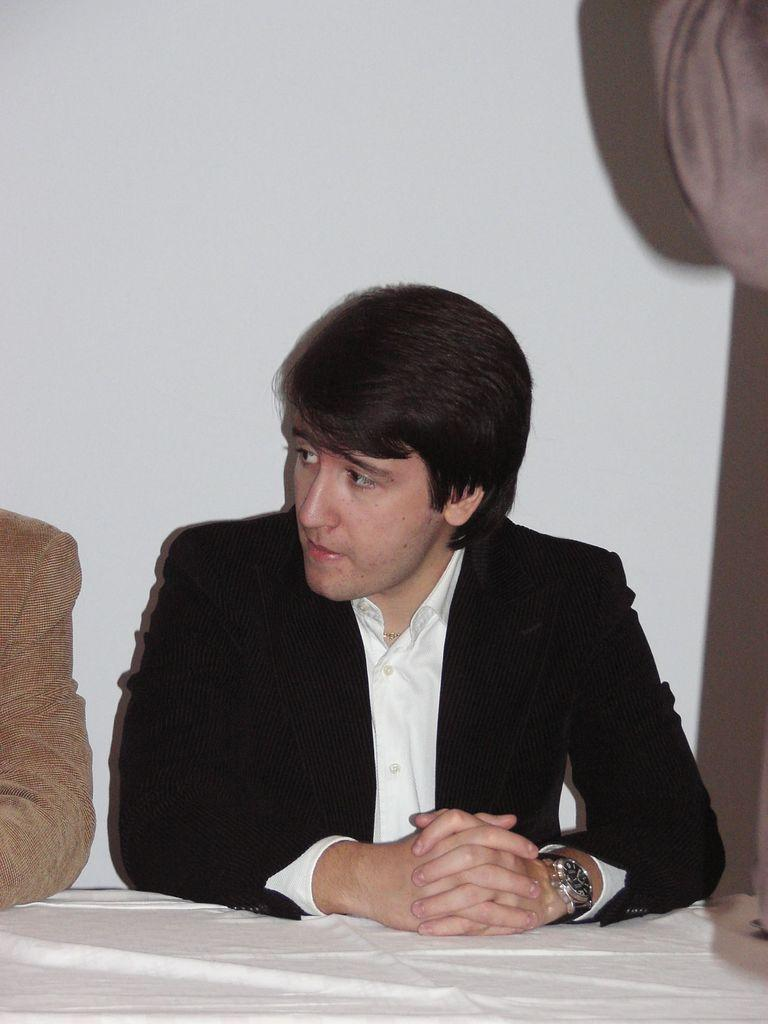What is the main subject of the image? The main subject of the image is a man. What is the man doing in the image? The man is sitting in the image. What is the man wearing? The man is wearing a black suit and a white shirt. Can you describe the hands of the other persons in the image? There are hands of two persons beside the man. What is in front of the man? There is a table in front of the man. What color is the wall in the image? The wall is white in color. What type of silver object is being used by the giants in the image? There are no giants or silver objects present in the image. Is the man driving a vehicle in the image? No, the man is sitting and there is no vehicle present in the image. 